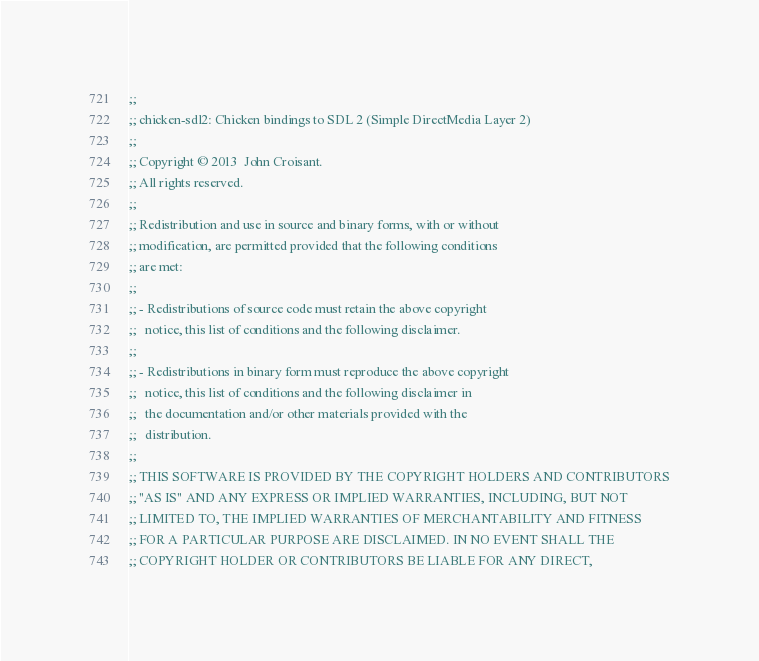<code> <loc_0><loc_0><loc_500><loc_500><_Scheme_>;;
;; chicken-sdl2: Chicken bindings to SDL 2 (Simple DirectMedia Layer 2)
;;
;; Copyright © 2013  John Croisant.
;; All rights reserved.
;;
;; Redistribution and use in source and binary forms, with or without
;; modification, are permitted provided that the following conditions
;; are met:
;;
;; - Redistributions of source code must retain the above copyright
;;   notice, this list of conditions and the following disclaimer.
;;
;; - Redistributions in binary form must reproduce the above copyright
;;   notice, this list of conditions and the following disclaimer in
;;   the documentation and/or other materials provided with the
;;   distribution.
;;
;; THIS SOFTWARE IS PROVIDED BY THE COPYRIGHT HOLDERS AND CONTRIBUTORS
;; "AS IS" AND ANY EXPRESS OR IMPLIED WARRANTIES, INCLUDING, BUT NOT
;; LIMITED TO, THE IMPLIED WARRANTIES OF MERCHANTABILITY AND FITNESS
;; FOR A PARTICULAR PURPOSE ARE DISCLAIMED. IN NO EVENT SHALL THE
;; COPYRIGHT HOLDER OR CONTRIBUTORS BE LIABLE FOR ANY DIRECT,</code> 